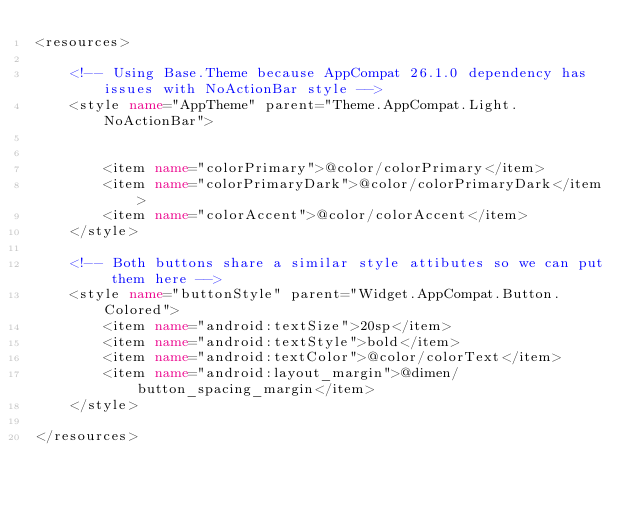<code> <loc_0><loc_0><loc_500><loc_500><_XML_><resources>

    <!-- Using Base.Theme because AppCompat 26.1.0 dependency has issues with NoActionBar style -->
    <style name="AppTheme" parent="Theme.AppCompat.Light.NoActionBar">


        <item name="colorPrimary">@color/colorPrimary</item>
        <item name="colorPrimaryDark">@color/colorPrimaryDark</item>
        <item name="colorAccent">@color/colorAccent</item>
    </style>

    <!-- Both buttons share a similar style attibutes so we can put them here -->
    <style name="buttonStyle" parent="Widget.AppCompat.Button.Colored">
        <item name="android:textSize">20sp</item>
        <item name="android:textStyle">bold</item>
        <item name="android:textColor">@color/colorText</item>
        <item name="android:layout_margin">@dimen/button_spacing_margin</item>
    </style>

</resources>
</code> 